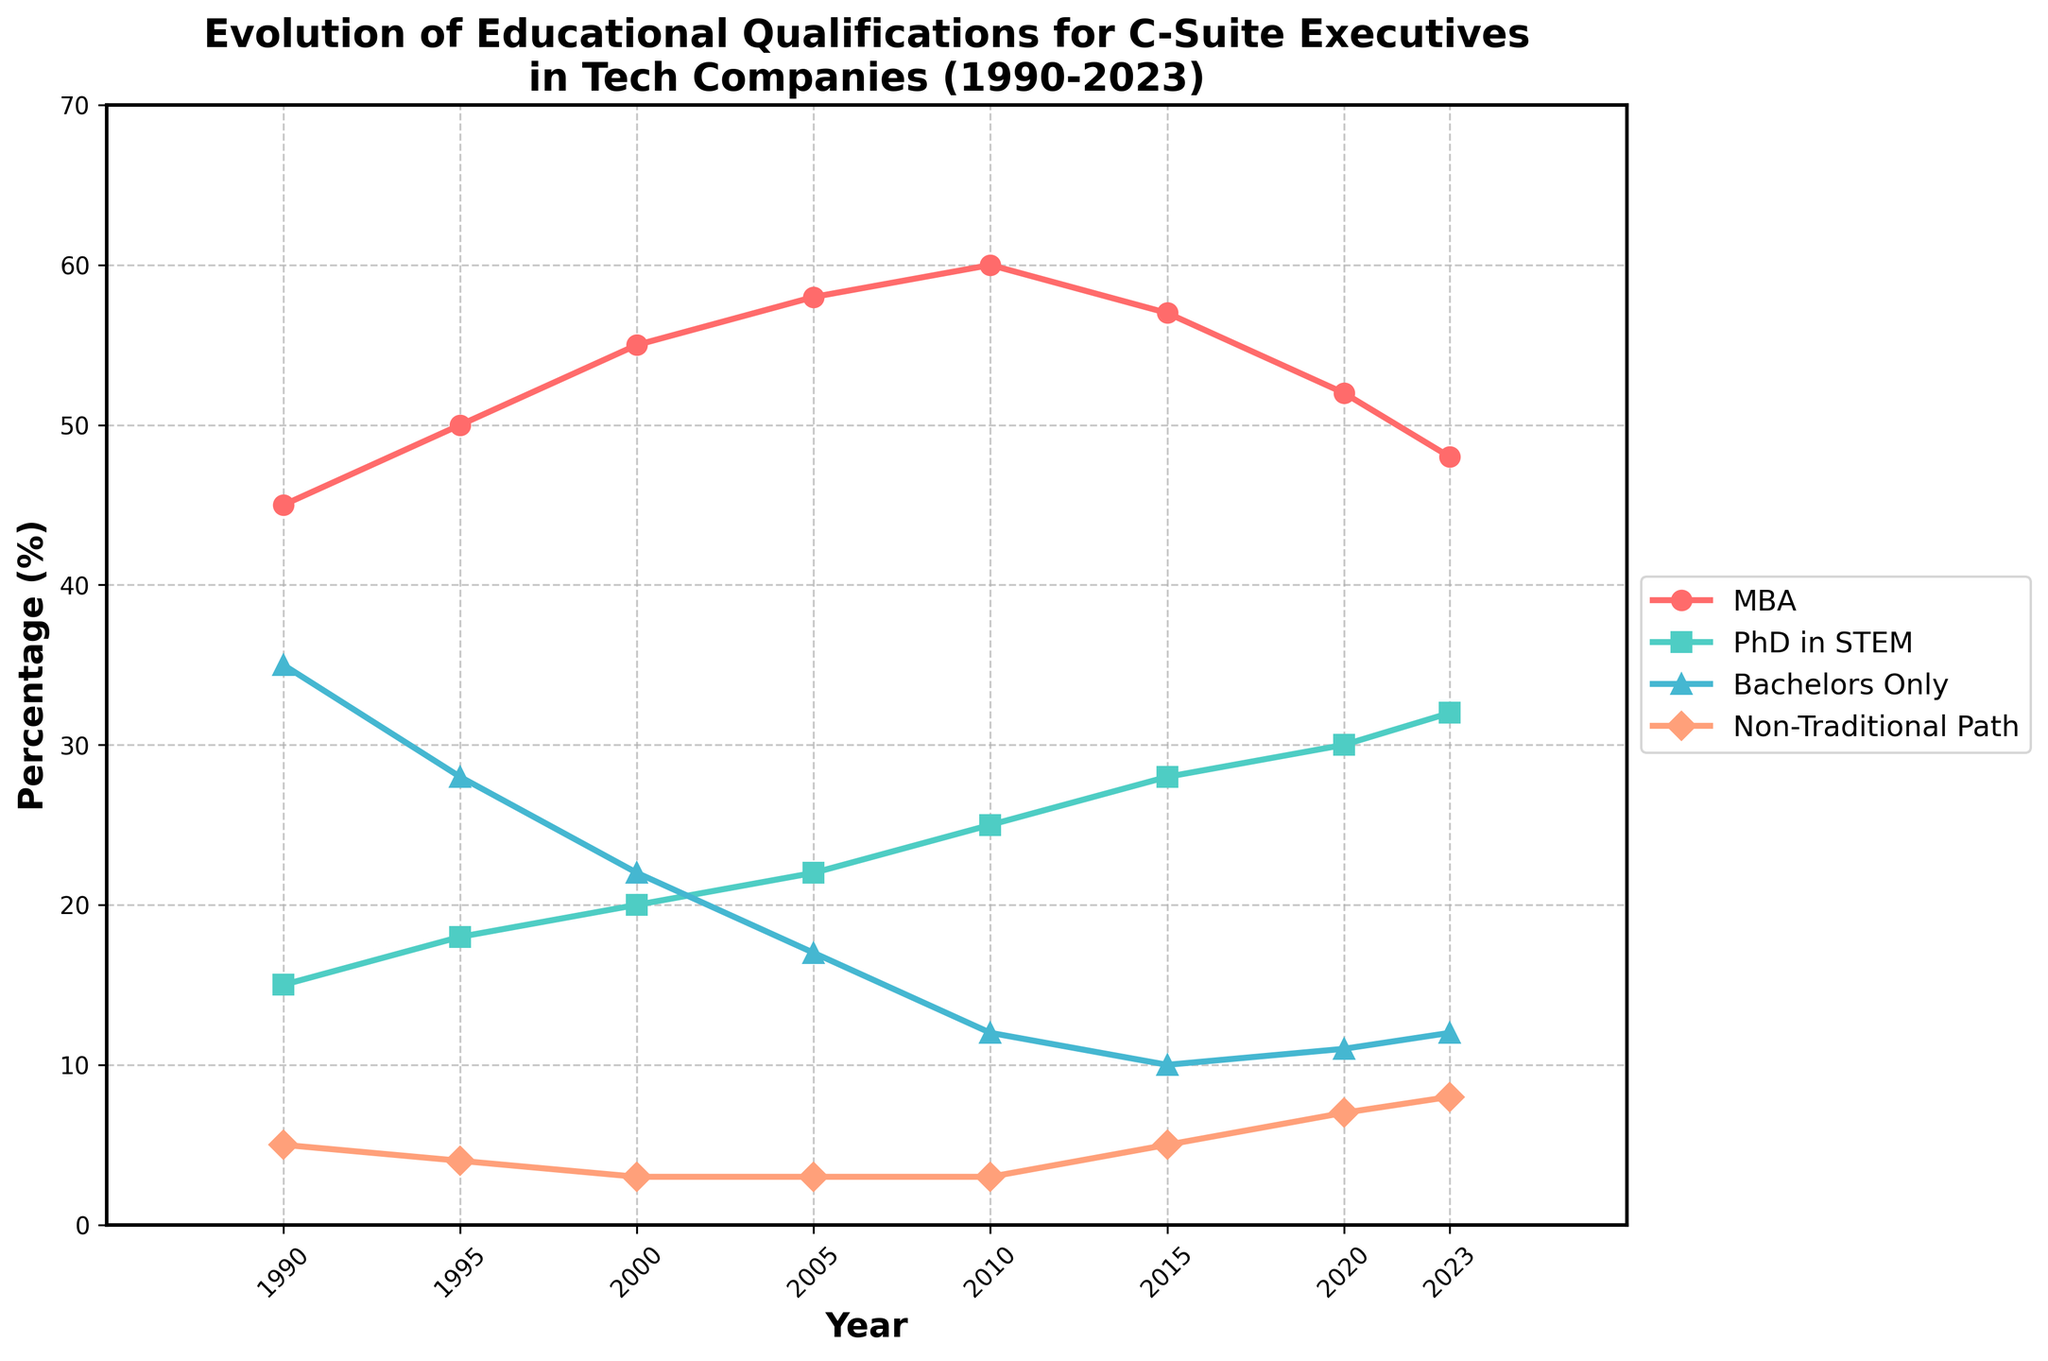What's the trend for MBAs from 1990 to 2023? To observe the trend, look at the line representing MBAs. It starts at 45% in 1990, increases to 60% in 2010, and then decreases to 48% by 2023.
Answer: Increasing, then decreasing Which qualification saw the greatest percentage increase from 1990 to 2023? Calculate the difference for each qualification. MBAs increased from 45% to 48% (+3%), PhDs in STEM increased from 15% to 32% (+17%), Bachelors Only decreased from 35% to 12% (-23%), and Non-Traditional Paths increased from 5% to 8% (+3%). The greatest increase is in PhDs in STEM.
Answer: PhD in STEM Between Bachelors Only and Non-Traditional Path in 2023, which one has a higher percentage? Compare the values for Bachelors Only (12%) and Non-Traditional Path (8%) in 2023.
Answer: Bachelors Only From which year did MBAs start declining? Identify the year where MBAs begin to decline after increasing. The peak is in 2010 at 60%, and it starts declining afterward.
Answer: 2010 What is the difference in percentages between MBAs and PhDs in STEM in 2023? Subtract the percentage for PhDs in STEM (32%) from MBAs (48%) in 2023.
Answer: 16% In which year did Non-Traditional Paths surpass 5%? Find the first year where the percentage for Non-Traditional Paths exceeds 5%. This occurs in 2015.
Answer: 2015 How does the percentage of Bachelors Only change from 1990 to 2023? Look at the trend line for Bachelors Only. It starts at 35% in 1990 and declines to 12% in 2023.
Answer: Decreases What is the sum of all four qualifications' percentages in 2000? Add the values for 2000: MBAs (55%), PhDs in STEM (20%), Bachelors Only (22%), and Non-Traditional Path (3%). 55 + 20 + 22 + 3 = 100%.
Answer: 100% Which qualification has the most stable percentage over the years? Observe the lines to see which one has the least variation. Non-Traditional Path stays quite stable around 3-8%.
Answer: Non-Traditional Path How many total percentage points did PhDs in STEM increase by from 2000 to 2023? Subtract the value for PhDs in STEM in 2000 (20%) from the value in 2023 (32%). 32% - 20% = 12%.
Answer: 12% 